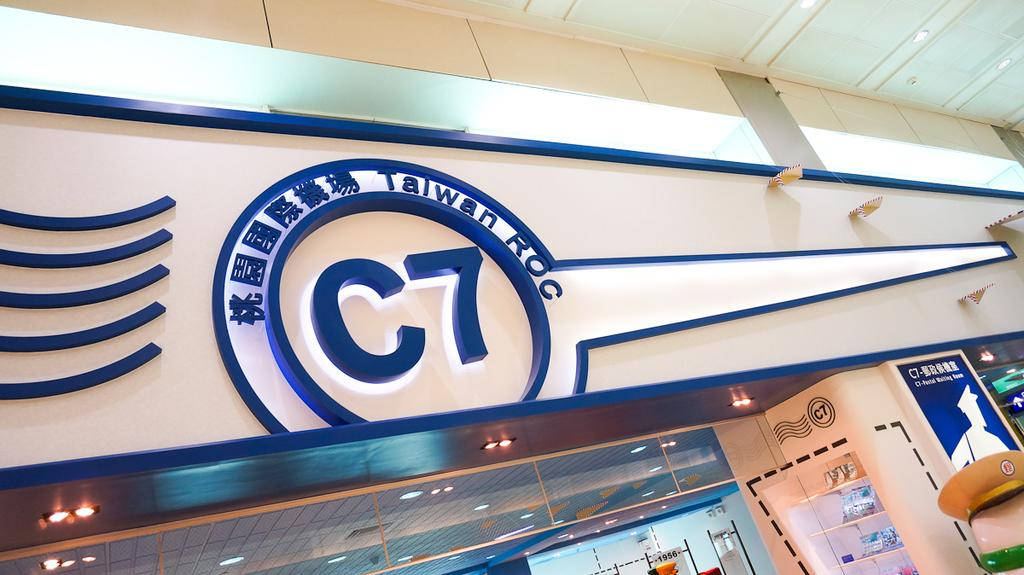What type of location is depicted in the image? The image is an inside picture of a building. Can you tell me how many men are currently standing near the head of the building in the image? There is no information about men, current events, or the head of the building in the image, so this question cannot be answered definitively. 